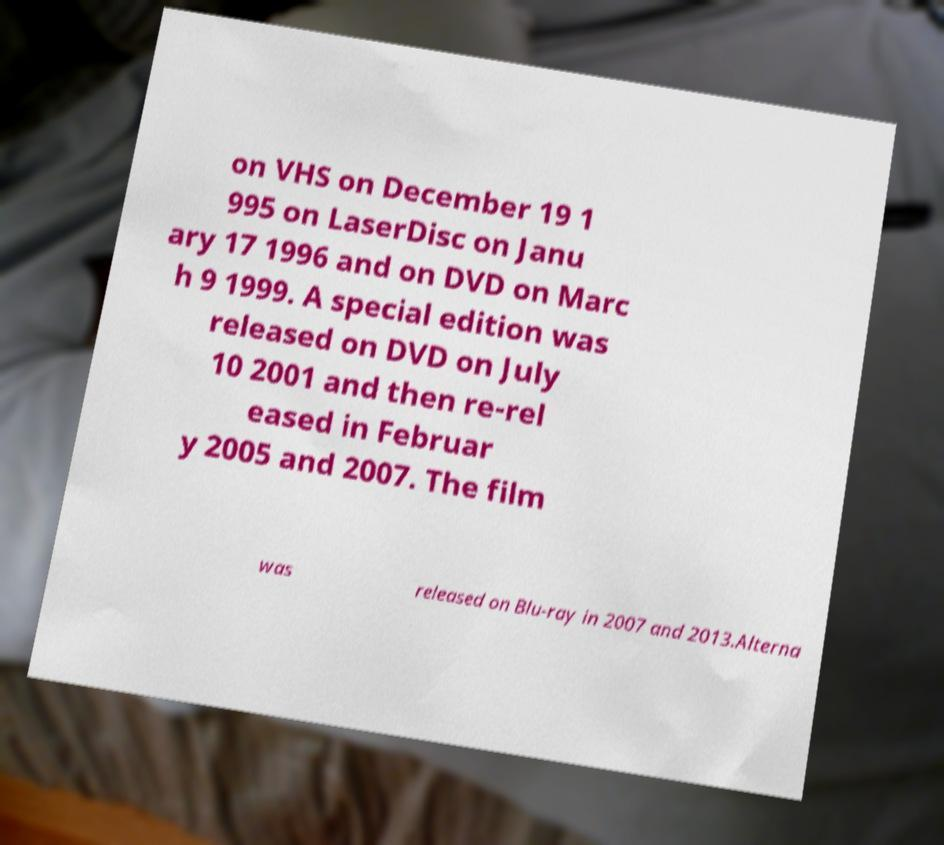For documentation purposes, I need the text within this image transcribed. Could you provide that? on VHS on December 19 1 995 on LaserDisc on Janu ary 17 1996 and on DVD on Marc h 9 1999. A special edition was released on DVD on July 10 2001 and then re-rel eased in Februar y 2005 and 2007. The film was released on Blu-ray in 2007 and 2013.Alterna 